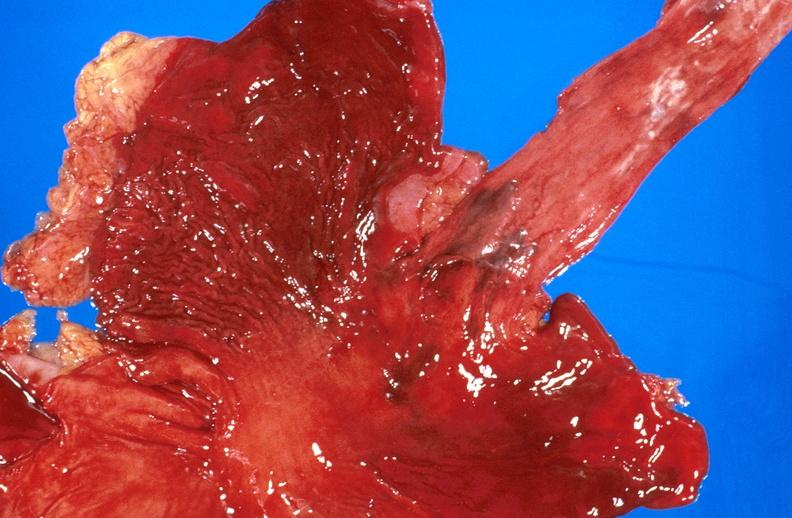s gastrointestinal present?
Answer the question using a single word or phrase. Yes 